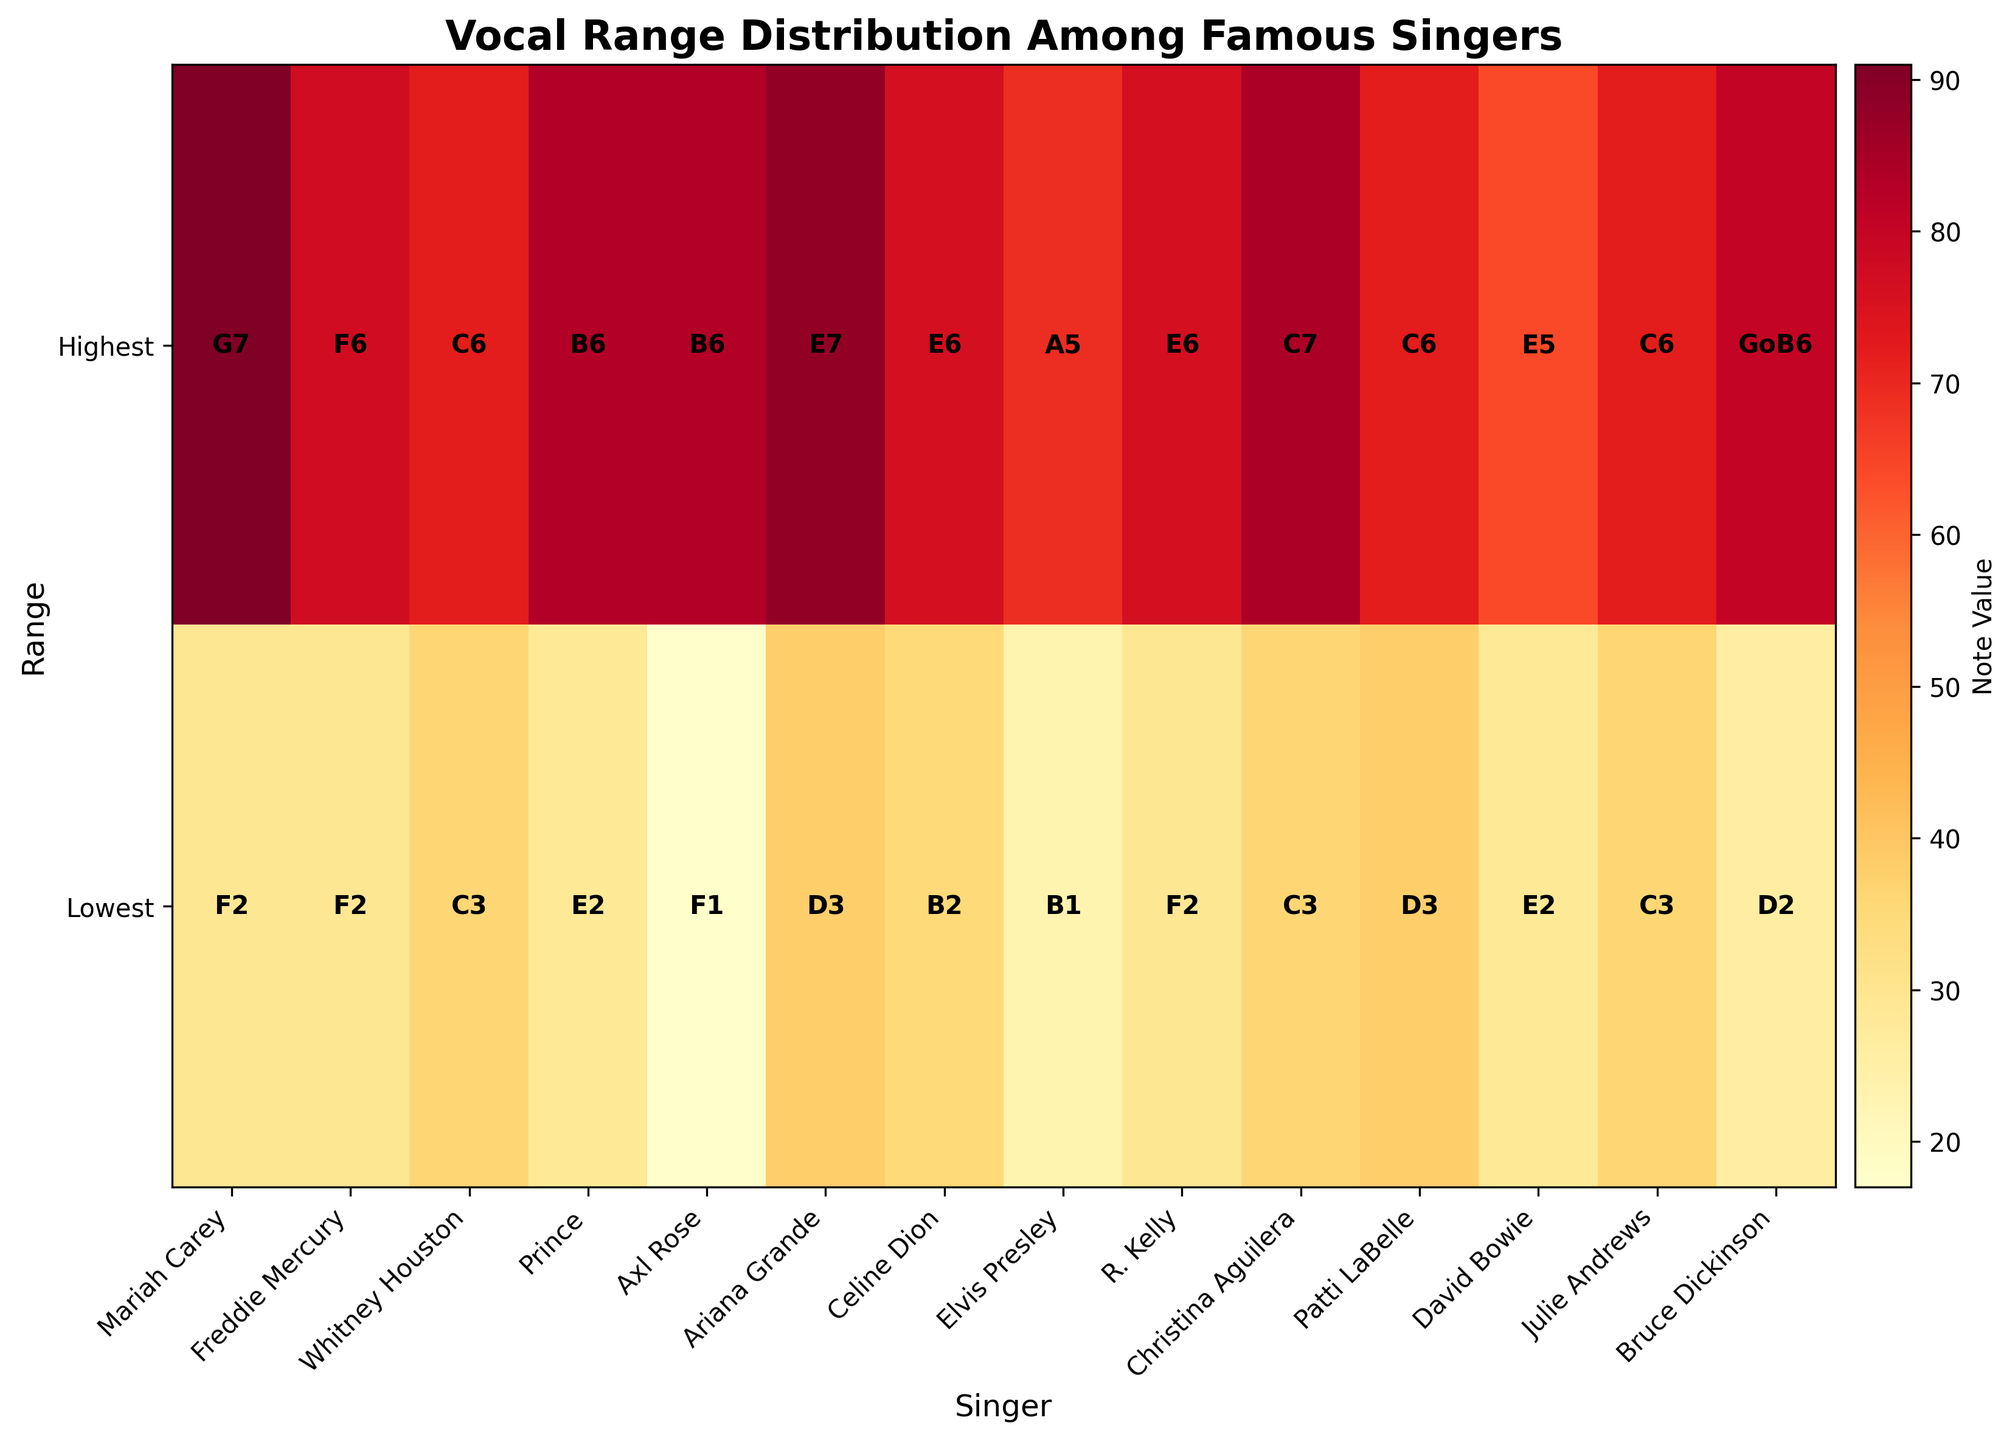how many singers are included in the plot? To determine the number of singers, you can count the number of tick marks on the x-axis, as each tick corresponds to a singer.
Answer: 14 Which singer has the widest vocal range? Identify the singer with the greatest numerical difference between their lowest and highest notes, as indicated by the annotations within the heatmap.
Answer: Axl Rose What's the title of the heatmap? The title is displayed at the top of the heatmap in bold font.
Answer: Vocal Range Distribution Among Famous Singers Who can sing the highest note? Look at the annotations on the heatmap for the highest notes and find the singer with the highest value.
Answer: Mariah Carey What is the range of R. Kelly's vocal notes? Check the heatmap annotations for R. Kelly and note the lowest and highest notes given.
Answer: F2 to E6 Which two singers have the same lowest note? Find singers whose annotations on the "Lowest" row of the heatmap match each other.
Answer: Mariah Carey and Freddie Mercury How many singers have a highest note above G5? Count the singers whose highest note annotations on the heatmap are higher than G5.
Answer: 9 Which singer has the lowest start note in the heatmap? Find the singer whose annotation in the "Lowest" row has the lowest note value.
Answer: Axl Rose What's the difference in the lowest note between Axl Rose and Elvis Presley? Subtract the note value of Elvis Presley's lowest note from that of Axl Rose's lowest note.
Answer: 6 semitones (F1 - B1) How many octaves can Prince sing across based on his highest and lowest notes? Convert the lowest and highest notes of Prince into their numerical values and then calculate the difference divided by 12 (one octave).
Answer: 4.5 octaves 